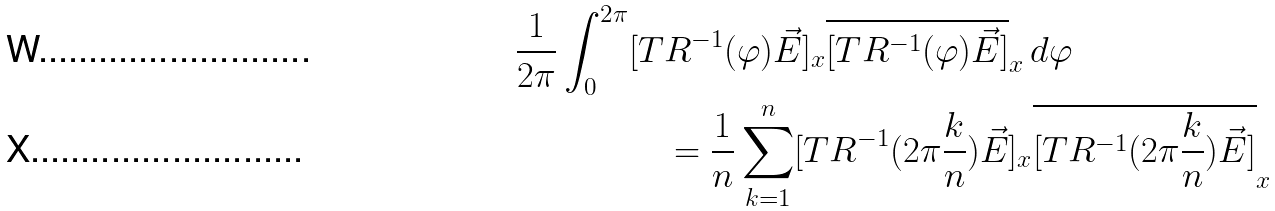<formula> <loc_0><loc_0><loc_500><loc_500>\frac { 1 } { 2 \pi } \int _ { 0 } ^ { 2 \pi } [ T & R ^ { - 1 } ( \varphi ) \vec { E } ] _ { x } \overline { [ T R ^ { - 1 } ( \varphi ) \vec { E } ] } _ { x } \, d \varphi \\ & = \frac { 1 } { n } \sum _ { k = 1 } ^ { n } [ T R ^ { - 1 } ( { 2 \pi \frac { k } { n } } ) \vec { E } ] _ { x } \overline { [ T R ^ { - 1 } ( { 2 \pi \frac { k } { n } } ) \vec { E } ] } _ { x }</formula> 